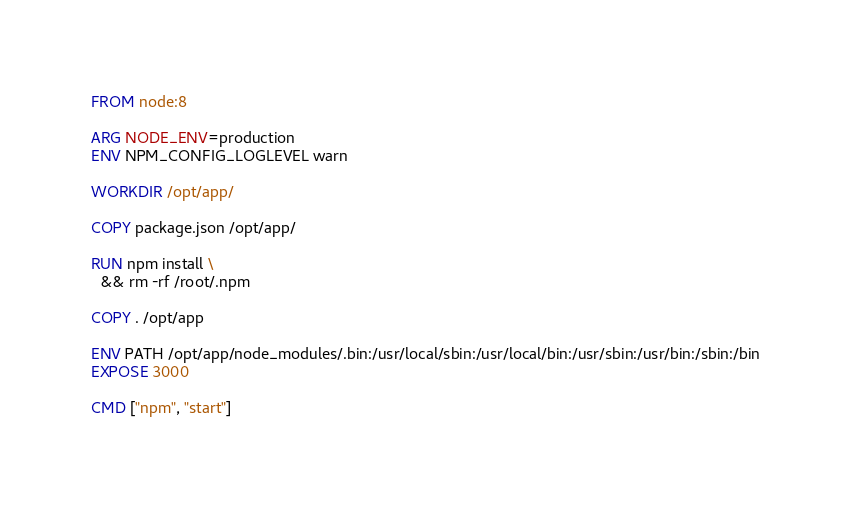Convert code to text. <code><loc_0><loc_0><loc_500><loc_500><_Dockerfile_>FROM node:8

ARG NODE_ENV=production
ENV NPM_CONFIG_LOGLEVEL warn

WORKDIR /opt/app/

COPY package.json /opt/app/

RUN npm install \
  && rm -rf /root/.npm

COPY . /opt/app

ENV PATH /opt/app/node_modules/.bin:/usr/local/sbin:/usr/local/bin:/usr/sbin:/usr/bin:/sbin:/bin
EXPOSE 3000

CMD ["npm", "start"]
</code> 